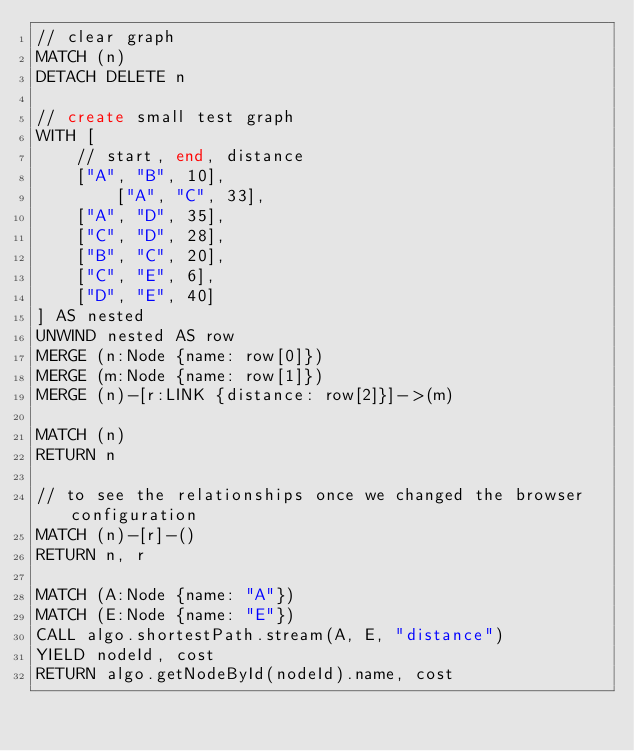<code> <loc_0><loc_0><loc_500><loc_500><_SQL_>// clear graph
MATCH (n)
DETACH DELETE n

// create small test graph
WITH [	
    // start, end, distance
	["A", "B", 10],
      	["A", "C", 33],
	["A", "D", 35],
	["C", "D", 28],
	["B", "C", 20],
	["C", "E", 6],
	["D", "E", 40]
] AS nested
UNWIND nested AS row
MERGE (n:Node {name: row[0]})
MERGE (m:Node {name: row[1]})
MERGE (n)-[r:LINK {distance: row[2]}]->(m)

MATCH (n)
RETURN n

// to see the relationships once we changed the browser configuration
MATCH (n)-[r]-()
RETURN n, r

MATCH (A:Node {name: "A"})
MATCH (E:Node {name: "E"})
CALL algo.shortestPath.stream(A, E, "distance")
YIELD nodeId, cost
RETURN algo.getNodeById(nodeId).name, cost
</code> 